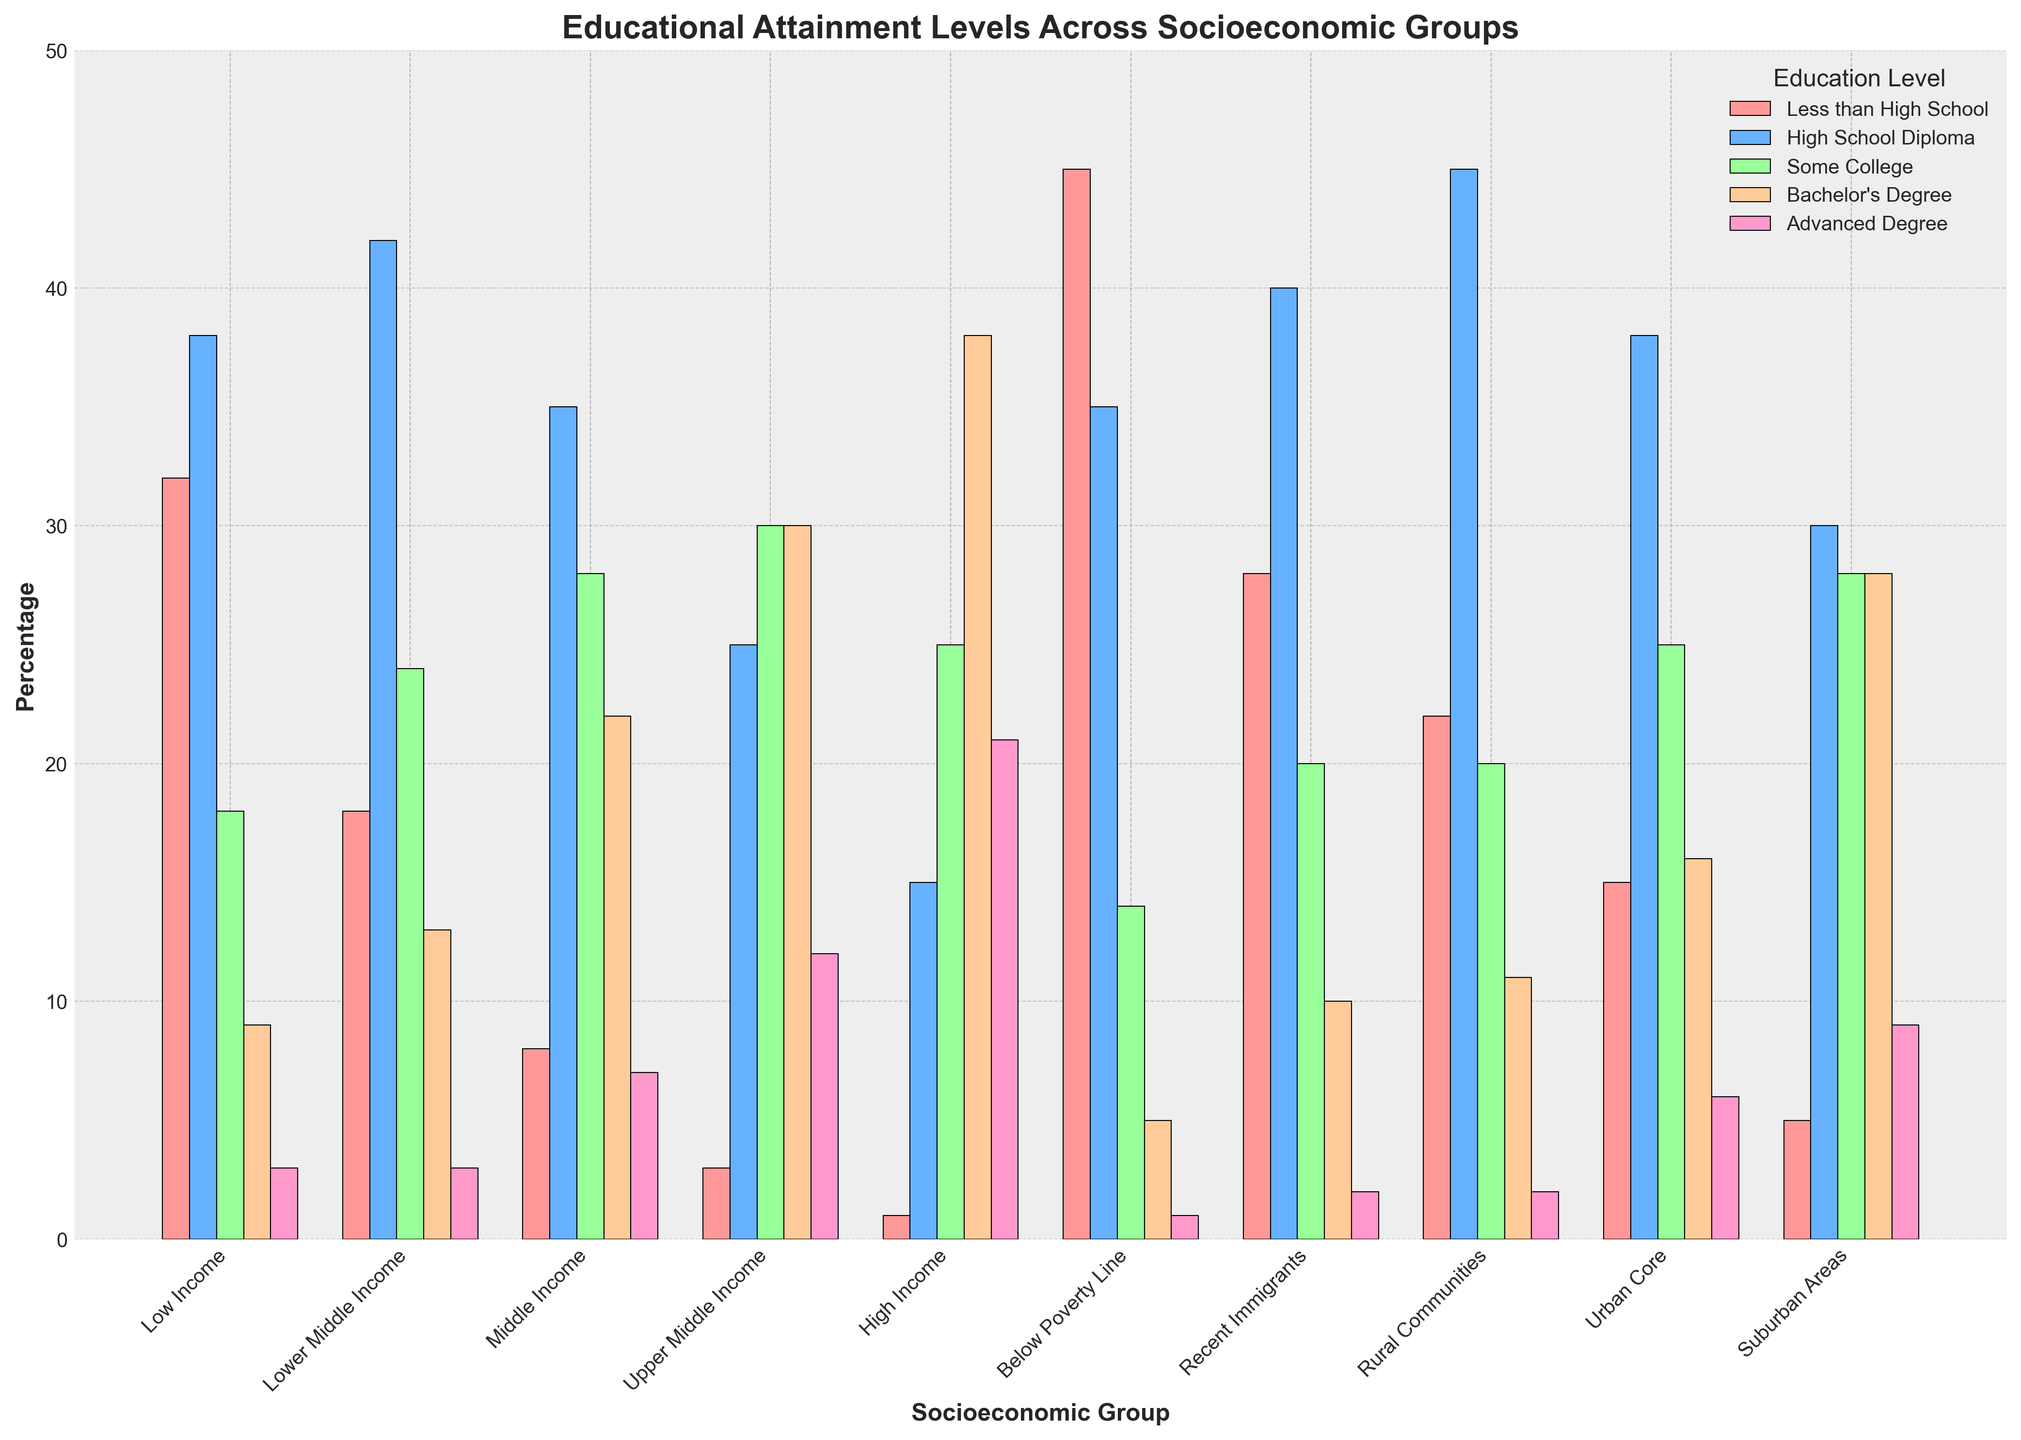Which socioeconomic group has the highest percentage of people with a Bachelor's Degree? To find the answer, look at the bars corresponding to a Bachelor's Degree (usually colored distinctly) across all groups. Identify the tallest bar among them. The group with the tallest bar for the Bachelor's Degree is the answer.
Answer: High Income Which socioeconomic group has the lowest percentage of people with an Advanced Degree? Look at the bars corresponding to Advanced Degree in each group. Identify the shortest bar among them. The shortest bar will tell you which group has the lowest percentage for an Advanced Degree.
Answer: Below Poverty Line Compare the percentage of people with a High School Diploma between Low Income and High Income groups. Which group has a higher percentage? Look at the bars for High School Diploma in both the Low Income and High Income groups. Compare the heights of the two bars to determine which is taller. The group with the taller bar has a higher percentage.
Answer: Low Income What is the approximate difference in the percentage of people with a Bachelor's Degree between Urban Core and Rural Communities? Find the bars for Bachelor's Degree within the Urban Core and Rural Communities groups. Subtract the height of the Rural Communities bar from the height of the Urban Core bar to get the difference.
Answer: Approximately 5% Which socioeconomic group has the highest combined percentage of people with less than a High School education and a High School Diploma? Add the percentages of Less than High School and High School Diploma for each group. Identify the group with the highest combined sum.
Answer: Below Poverty Line Is the percentage of individuals with some college education higher in Suburban Areas or Upper Middle Income groups? Look at the bars for Some College education in both Suburban Areas and Upper Middle Income groups. Compare the heights of these bars. The taller bar indicates a higher percentage.
Answer: Upper Middle Income What is the combined percentage of people with at least a Bachelor's Degree in Lower Middle Income group? Add the percentages of individuals with a Bachelor's Degree and Advanced Degree in the Lower Middle Income group to find the combined percentage.
Answer: 16% Which two groups have the closest percentage of people with a High School Diploma? Compare the bars for High School Diploma across all groups. Identify the two groups whose bars are almost equal in height.
Answer: Rural Communities and Lower Middle Income 